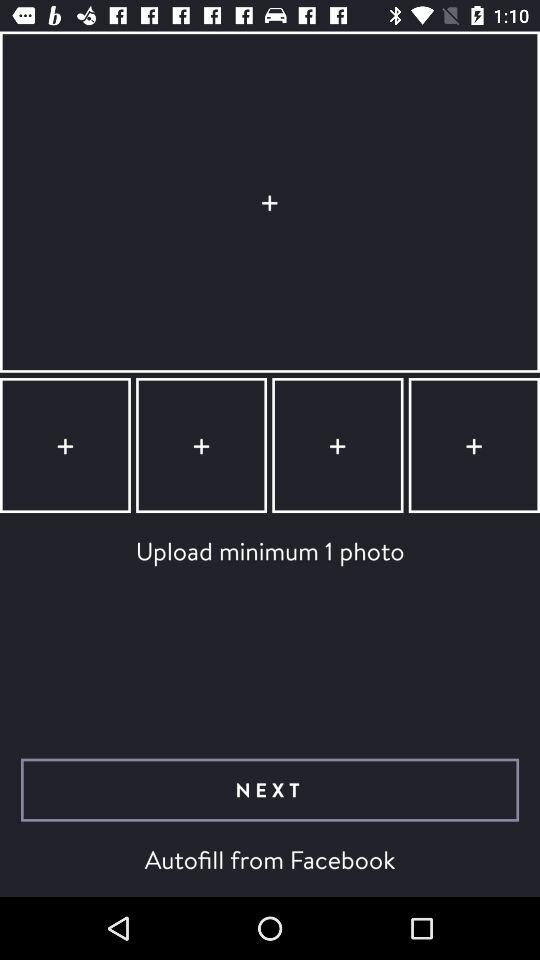What is the minimum number of photos that need to be uploaded? The minimum number of photos that need to be uploaded is 1. 